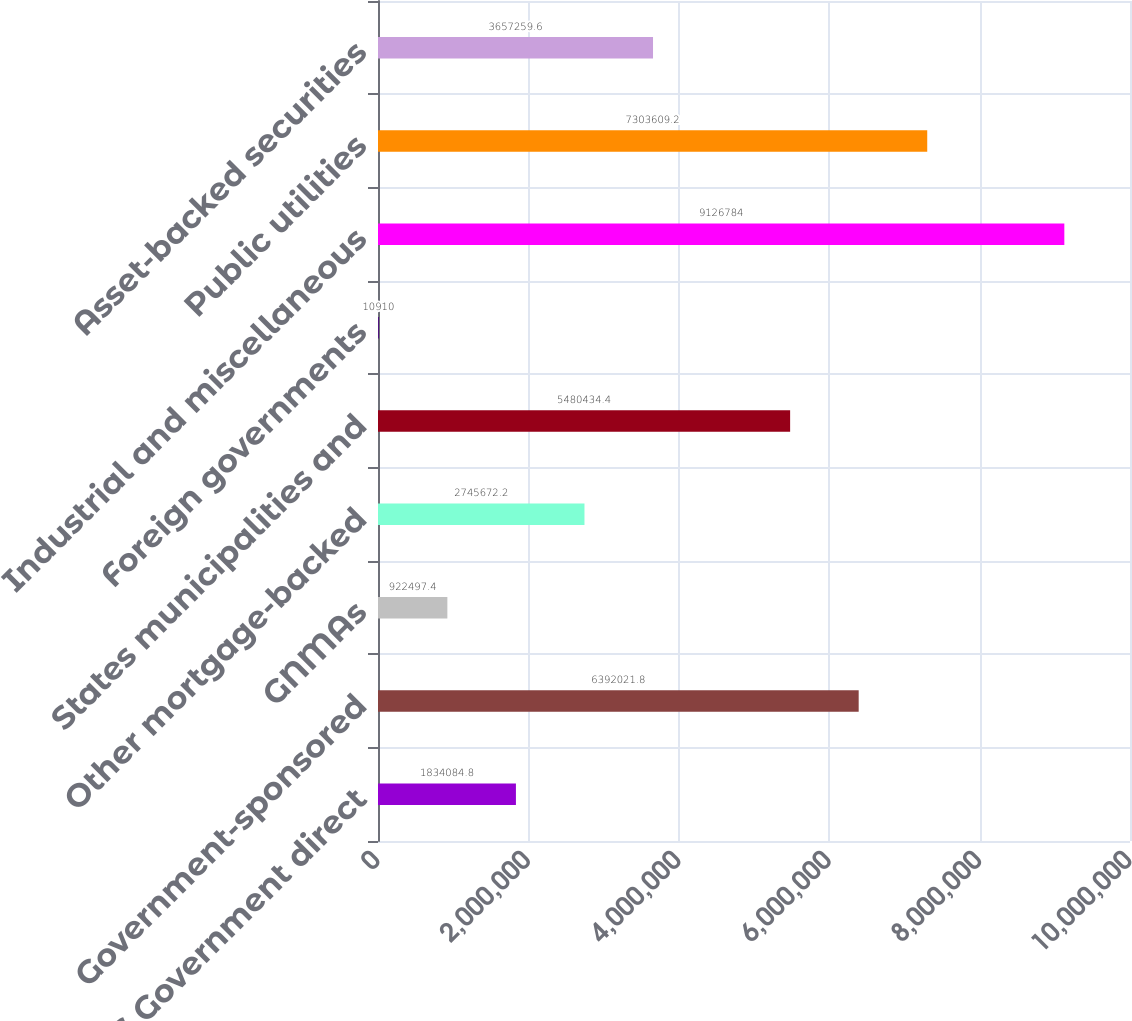Convert chart. <chart><loc_0><loc_0><loc_500><loc_500><bar_chart><fcel>US Government direct<fcel>Government-sponsored<fcel>GNMAs<fcel>Other mortgage-backed<fcel>States municipalities and<fcel>Foreign governments<fcel>Industrial and miscellaneous<fcel>Public utilities<fcel>Asset-backed securities<nl><fcel>1.83408e+06<fcel>6.39202e+06<fcel>922497<fcel>2.74567e+06<fcel>5.48043e+06<fcel>10910<fcel>9.12678e+06<fcel>7.30361e+06<fcel>3.65726e+06<nl></chart> 